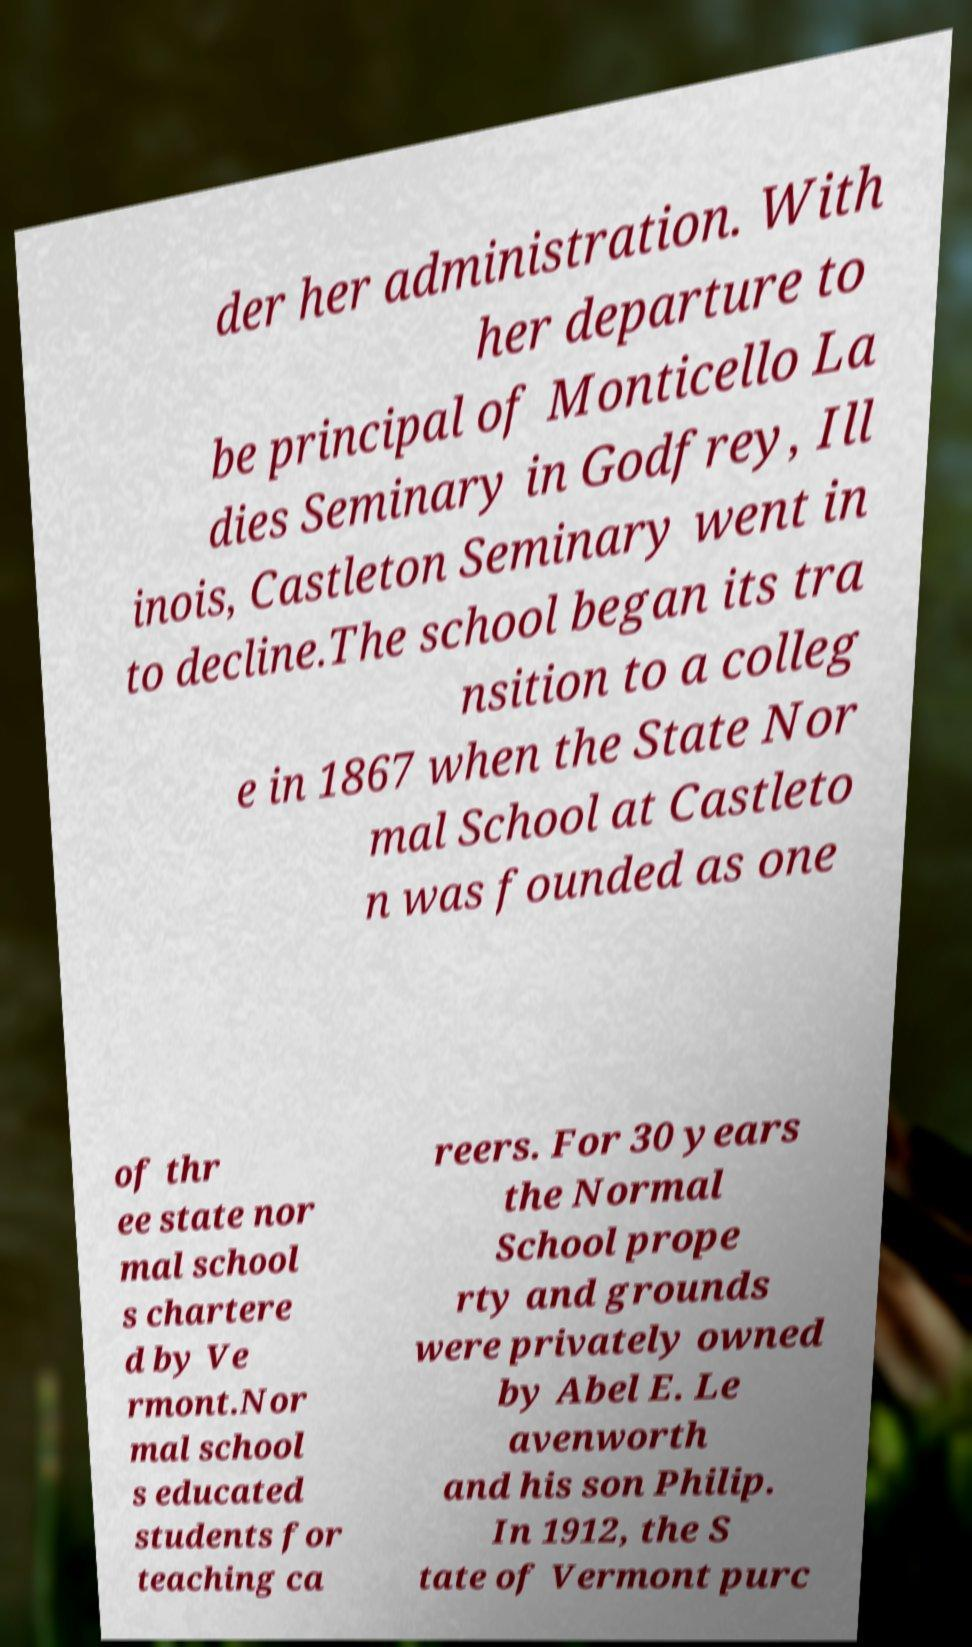Could you extract and type out the text from this image? der her administration. With her departure to be principal of Monticello La dies Seminary in Godfrey, Ill inois, Castleton Seminary went in to decline.The school began its tra nsition to a colleg e in 1867 when the State Nor mal School at Castleto n was founded as one of thr ee state nor mal school s chartere d by Ve rmont.Nor mal school s educated students for teaching ca reers. For 30 years the Normal School prope rty and grounds were privately owned by Abel E. Le avenworth and his son Philip. In 1912, the S tate of Vermont purc 